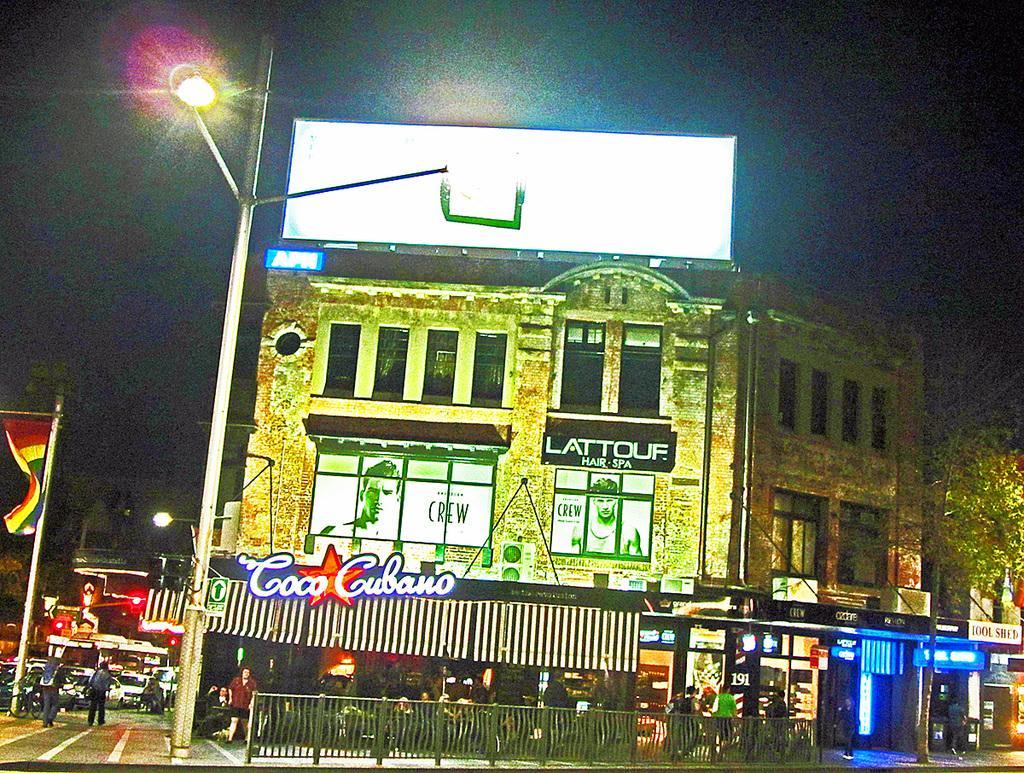Can you describe this image briefly? In this image in the center there is one building, and on the left side there are some vehicles and some persons are walking. And there are some poles, flags, lights and buildings. And at the bottom there is a fence and some people are walking on footpath. On the left side there are some trees and stores. In the center there is one pole and streetlight. 